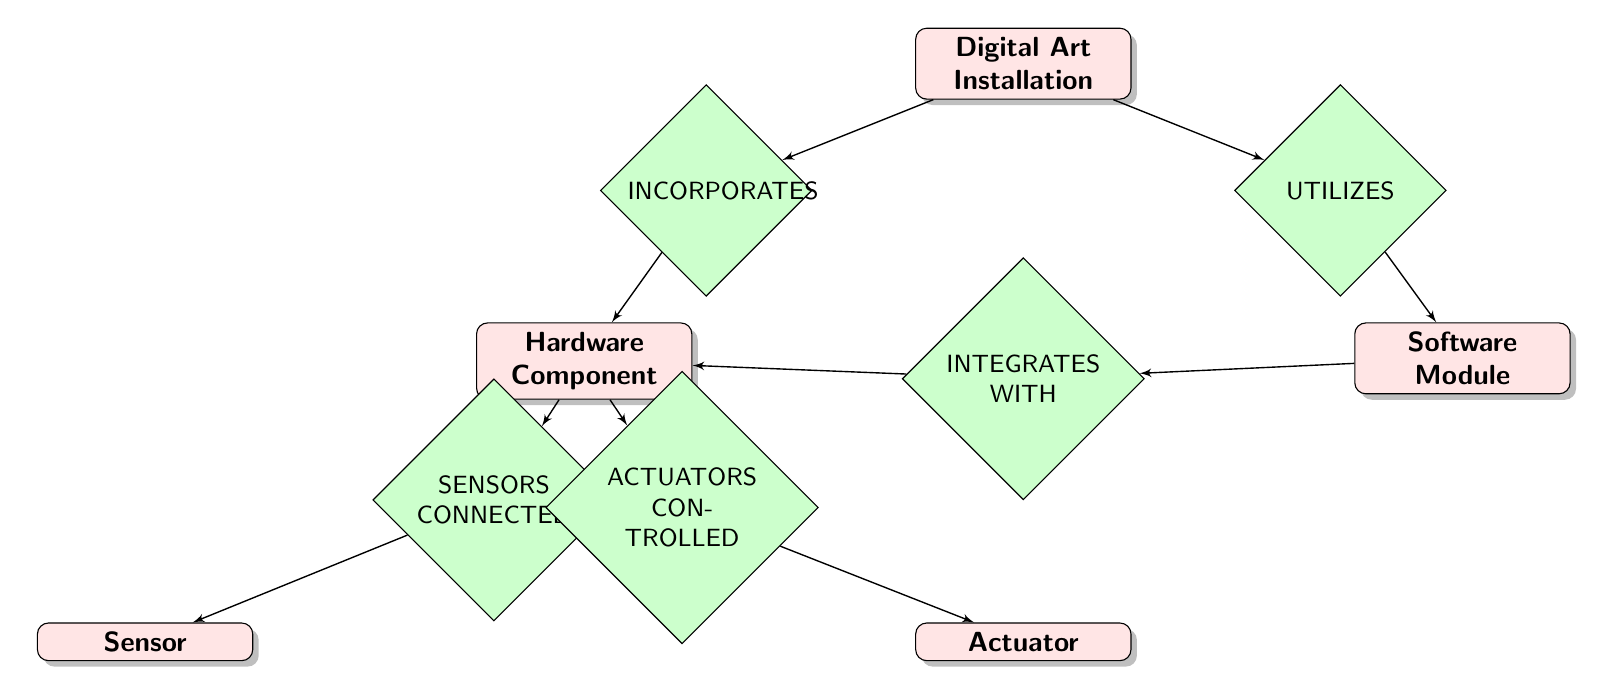What are the entities represented in the diagram? The diagram includes five entities: Digital Art Installation, Hardware Component, Software Module, Sensor, and Actuator.
Answer: Digital Art Installation, Hardware Component, Software Module, Sensor, Actuator How many relationships are shown in the diagram? There are five relationships depicted in the diagram: INCORPORATES, UTILIZES, SENSORS CONNECTED, ACTUATORS CONTROLLED, and INTEGRATES WITH. Count each relationship to find the total.
Answer: 5 Which entity has a relationship with Software Module? The Software Module is related to the Digital Art Installation through the UTILIZES relationship and with Hardware Component through the INTEGRATES WITH relationship. Here, the primary relationship is with Digital Art Installation.
Answer: Digital Art Installation What type of relationship connects Hardware Component and Sensor? The relationship connecting Hardware Component and Sensor is named SENSORS CONNECTED, indicating a direct integration of sensors within the hardware.
Answer: SENSORS CONNECTED How many sensors can connect to a Hardware Component? The diagram does not indicate any specific limit to the number of sensors that can connect to a Hardware Component; however, it shows a direct relationship representing the connection.
Answer: No specific limit Which entity is controlled by Actuator according to the diagram? The Actuator is related to the Hardware Component via the ACTUATORS CONTROLLED relationship, indicating that it controls or influences the behavior of the Hardware Component.
Answer: Hardware Component What is the direction of the relationship INCORPORATES? The direction of the INCORPORATES relationship indicates that the Digital Art Installation incorporates Hardware Components, signifying a unidirectional influence.
Answer: Digital Art Installation to Hardware Component Can Hardware Component also integrate with Software Module? Yes, the Hardware Component integrates with the Software Module through the INTEGRATES WITH relationship, indicating mutual interaction between hardware and software in the installation.
Answer: Yes 